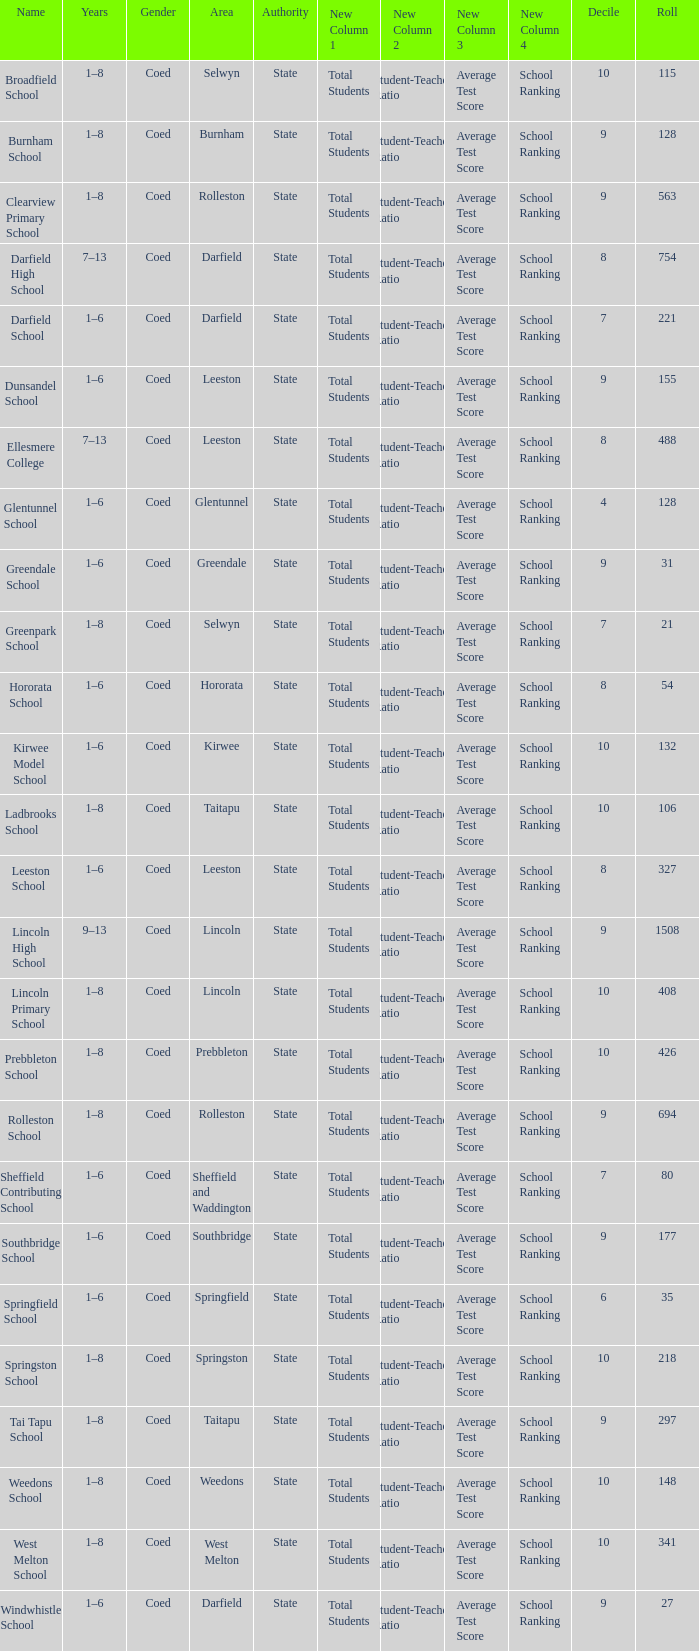Which area has a Decile of 9, and a Roll of 31? Greendale. 